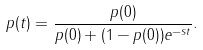<formula> <loc_0><loc_0><loc_500><loc_500>p ( t ) = \frac { p ( 0 ) } { p ( 0 ) + ( 1 - p ( 0 ) ) e ^ { - s t } } .</formula> 